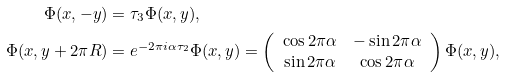<formula> <loc_0><loc_0><loc_500><loc_500>\Phi ( x , - y ) & = \tau _ { 3 } \Phi ( x , y ) , \\ \Phi ( x , y + 2 \pi R ) & = e ^ { - 2 \pi i \alpha \tau _ { 2 } } \Phi ( x , y ) = \left ( \begin{array} { c c } \cos 2 \pi \alpha & - \sin 2 \pi \alpha \\ \sin 2 \pi \alpha & \cos 2 \pi \alpha \end{array} \right ) \Phi ( x , y ) ,</formula> 